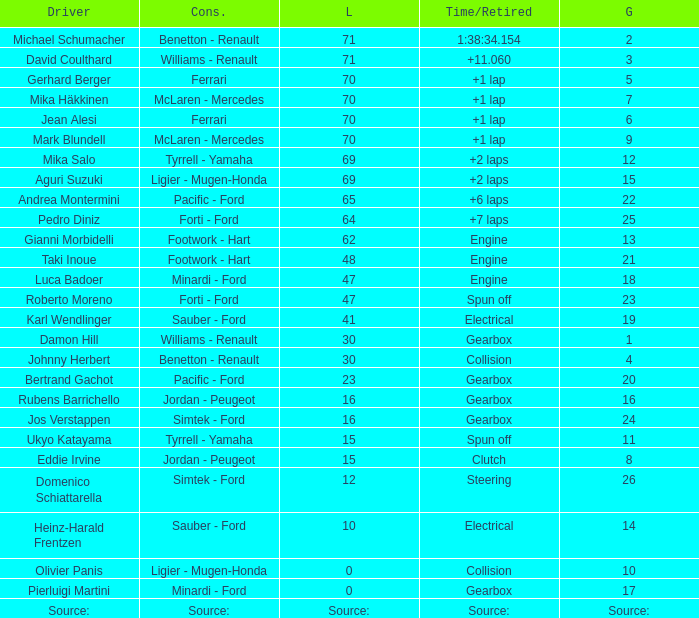How many laps were there in grid 21? 48.0. 